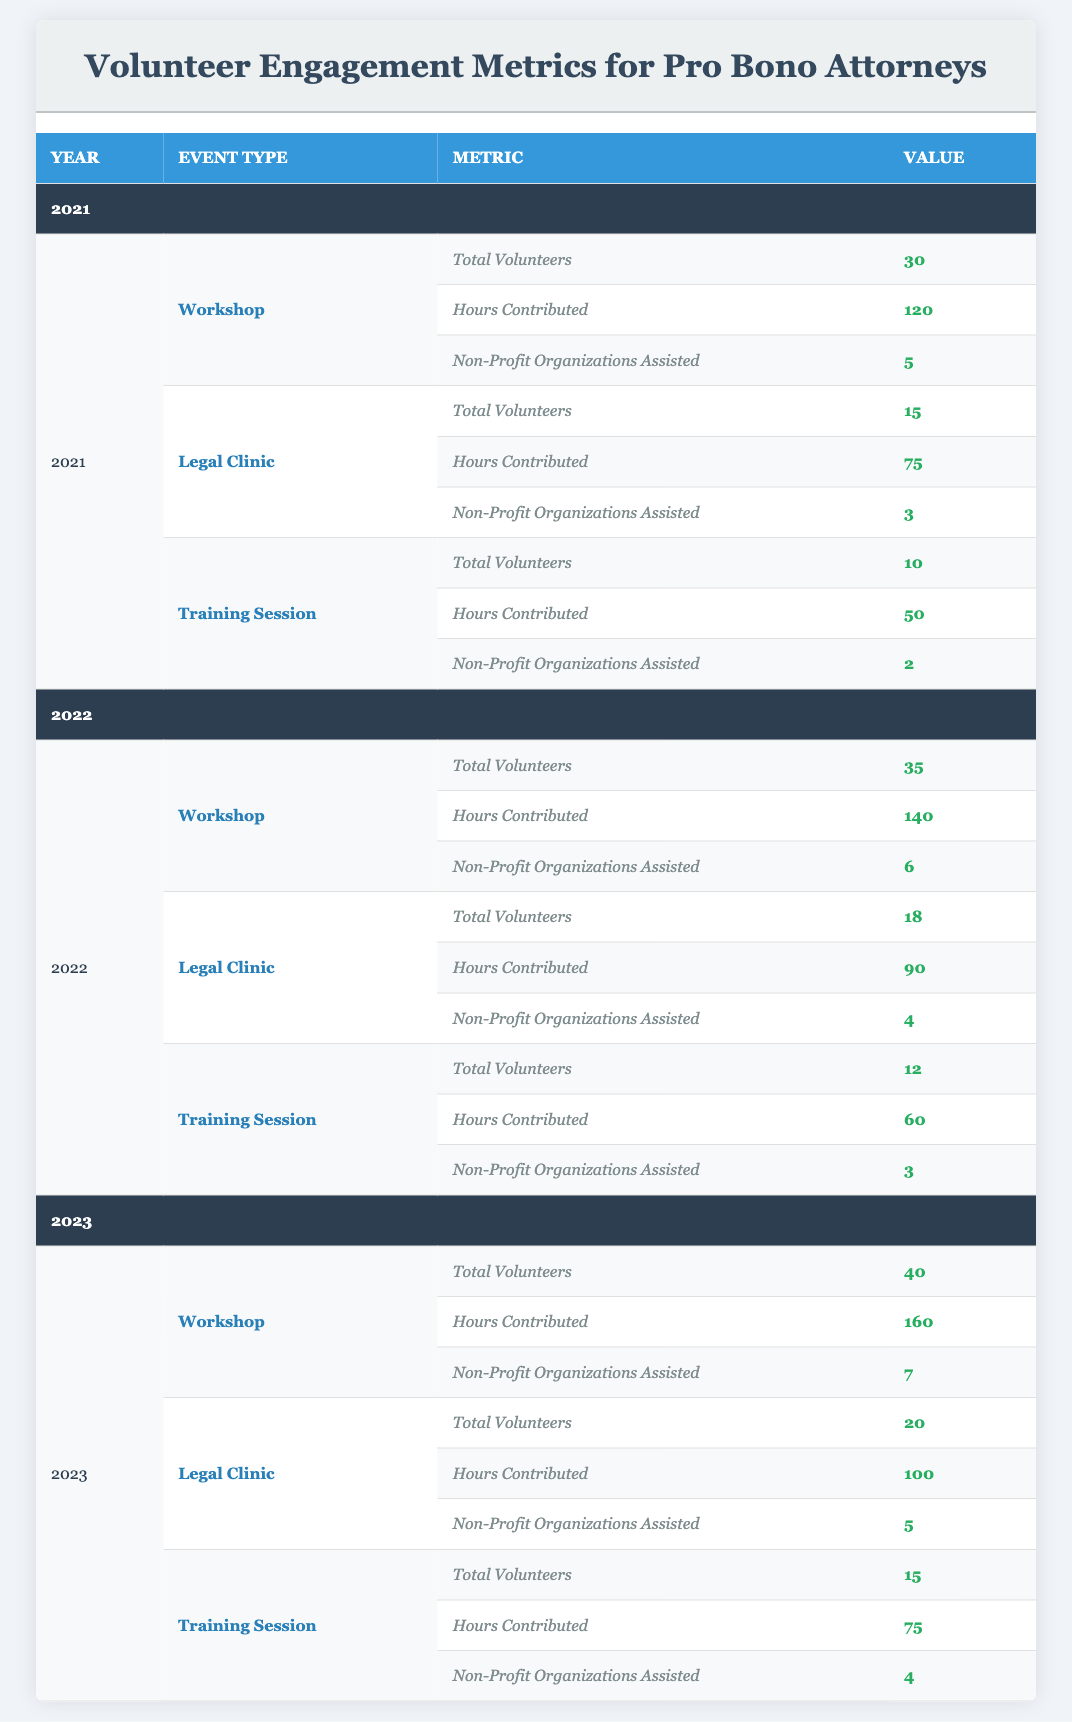What was the total number of volunteers for the Workshop in 2022? In the table, under the Workshop event type for the year 2022, the Total Volunteers is listed as 35.
Answer: 35 How many hours did volunteers contribute to the Legal Clinic in 2023? In the table, for the Legal Clinic in 2023, the Hours Contributed is stated as 100.
Answer: 100 Did the number of Non-Profit Organizations Assisted increase from 2021 to 2022 for the Training Session? In 2021, there were 2 Non-Profit Organizations Assisted for the Training Session, and in 2022, it increased to 3. Therefore, the statement is true.
Answer: Yes What is the average number of Total Volunteers across all event types in 2021? For 2021, the Total Volunteers are 30 (Workshop) + 15 (Legal Clinic) + 10 (Training Session) = 55. Divide this by 3 (number of event types) gives an average of 55/3 = 18.33.
Answer: 18.33 Which event type had the highest Total Volunteers in 2023? Referring to the 2023 data, the Workshop had the highest Total Volunteers with a count of 40, compared to 20 for the Legal Clinic and 15 for the Training Session.
Answer: Workshop How many Non-Profit Organizations were assisted in total across all 2022 events? The total for 2022 is 6 (Workshop) + 4 (Legal Clinic) + 3 (Training Session) = 13 Non-Profit Organizations assisted in total across all events.
Answer: 13 Has the total number of Hours Contributed to the Legal Clinic increased every year from 2021 to 2023? The Hours Contributed for the Legal Clinic were 75 (2021), 90 (2022), and 100 (2023). This confirms an increase each year, making the statement true.
Answer: Yes What was the increase in Total Volunteers for the Workshop from 2021 to 2023? The Total Volunteers for the Workshop increased from 30 (2021) to 40 (2023), resulting in an increase of 10 volunteers (40 - 30 = 10).
Answer: 10 Which year had the fewest Non-Profit Organizations Assisted in the Training Session? Looking at the Training Session data, in 2021, there were 2 Non-Profit Organizations assisted. In 2022, that number increased to 3, and in 2023, it was 4. Thus, 2021 had the fewest.
Answer: 2021 